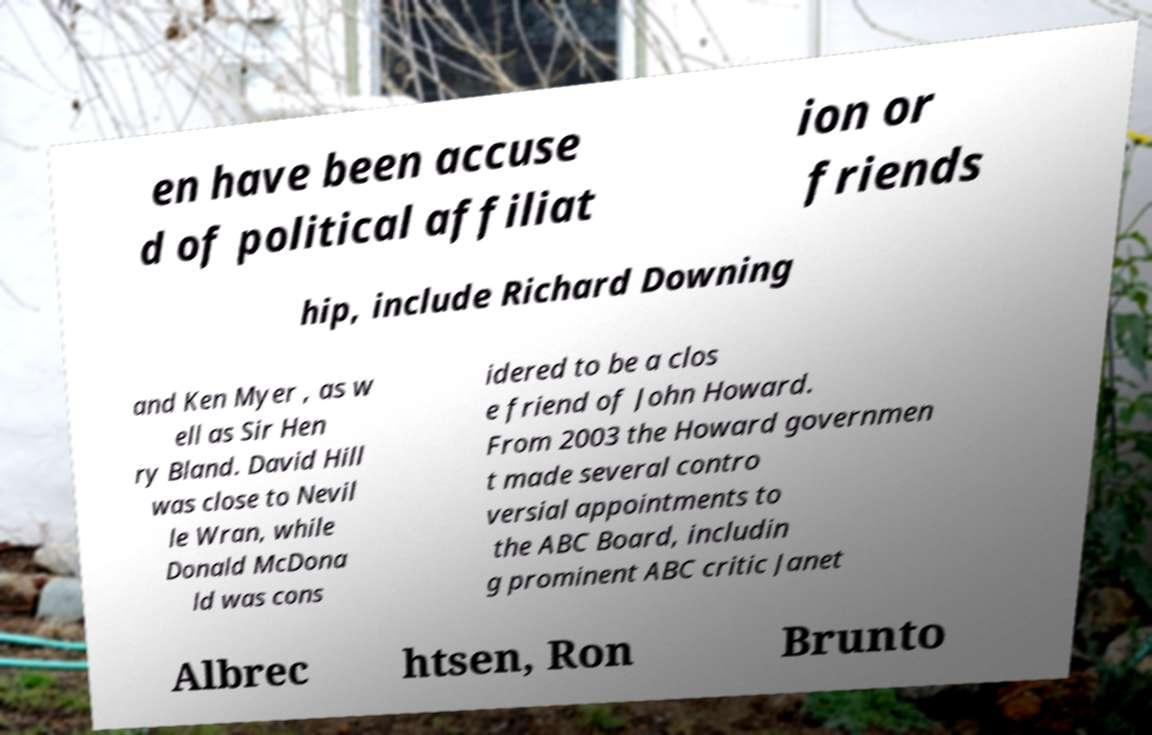Can you read and provide the text displayed in the image?This photo seems to have some interesting text. Can you extract and type it out for me? en have been accuse d of political affiliat ion or friends hip, include Richard Downing and Ken Myer , as w ell as Sir Hen ry Bland. David Hill was close to Nevil le Wran, while Donald McDona ld was cons idered to be a clos e friend of John Howard. From 2003 the Howard governmen t made several contro versial appointments to the ABC Board, includin g prominent ABC critic Janet Albrec htsen, Ron Brunto 